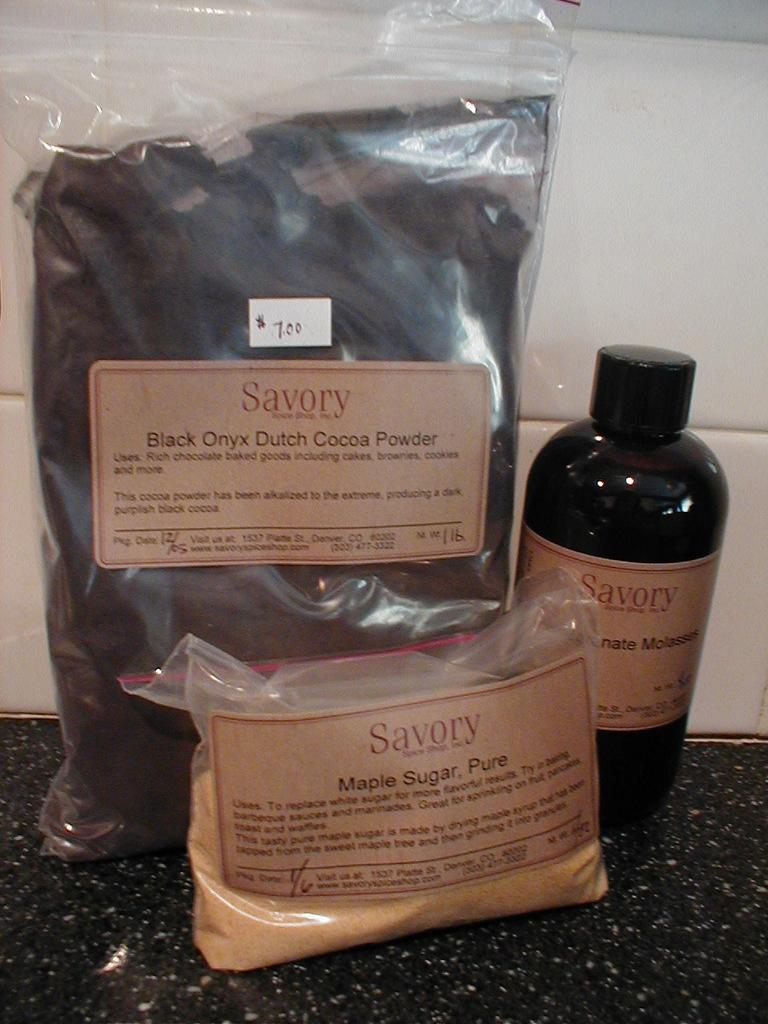<image>
Provide a brief description of the given image. A packet of Black Onyx Dutch Cocoa Powder and a packet of Maple Sugar, Pure. 